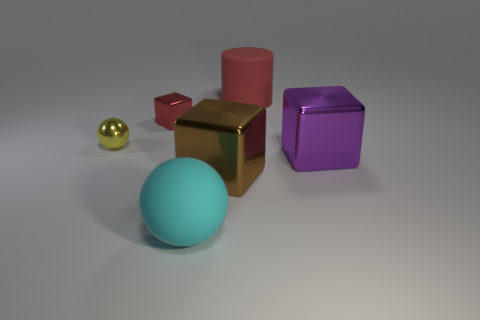There is a red thing that is left of the large cyan sphere; is there a metallic thing left of it?
Provide a succinct answer. Yes. Are there any tiny red metallic things on the left side of the cyan sphere?
Your answer should be very brief. Yes. Does the small metal object on the right side of the tiny metal sphere have the same shape as the large brown object?
Provide a succinct answer. Yes. How many big brown metallic objects are the same shape as the small yellow thing?
Your answer should be compact. 0. Is there a yellow thing made of the same material as the purple cube?
Ensure brevity in your answer.  Yes. There is a red object that is to the right of the ball in front of the big purple metal block; what is its material?
Provide a succinct answer. Rubber. What is the size of the ball in front of the yellow ball?
Make the answer very short. Large. Is the color of the large rubber cylinder the same as the metallic block that is to the left of the big cyan sphere?
Provide a short and direct response. Yes. Is there a matte thing of the same color as the small shiny cube?
Provide a short and direct response. Yes. Is the material of the cylinder the same as the sphere behind the large purple block?
Offer a very short reply. No. 